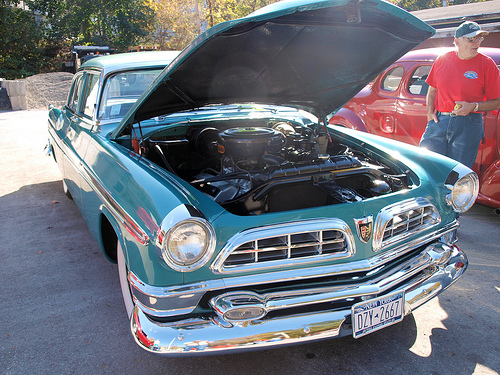<image>
Is the man to the left of the car? Yes. From this viewpoint, the man is positioned to the left side relative to the car. 